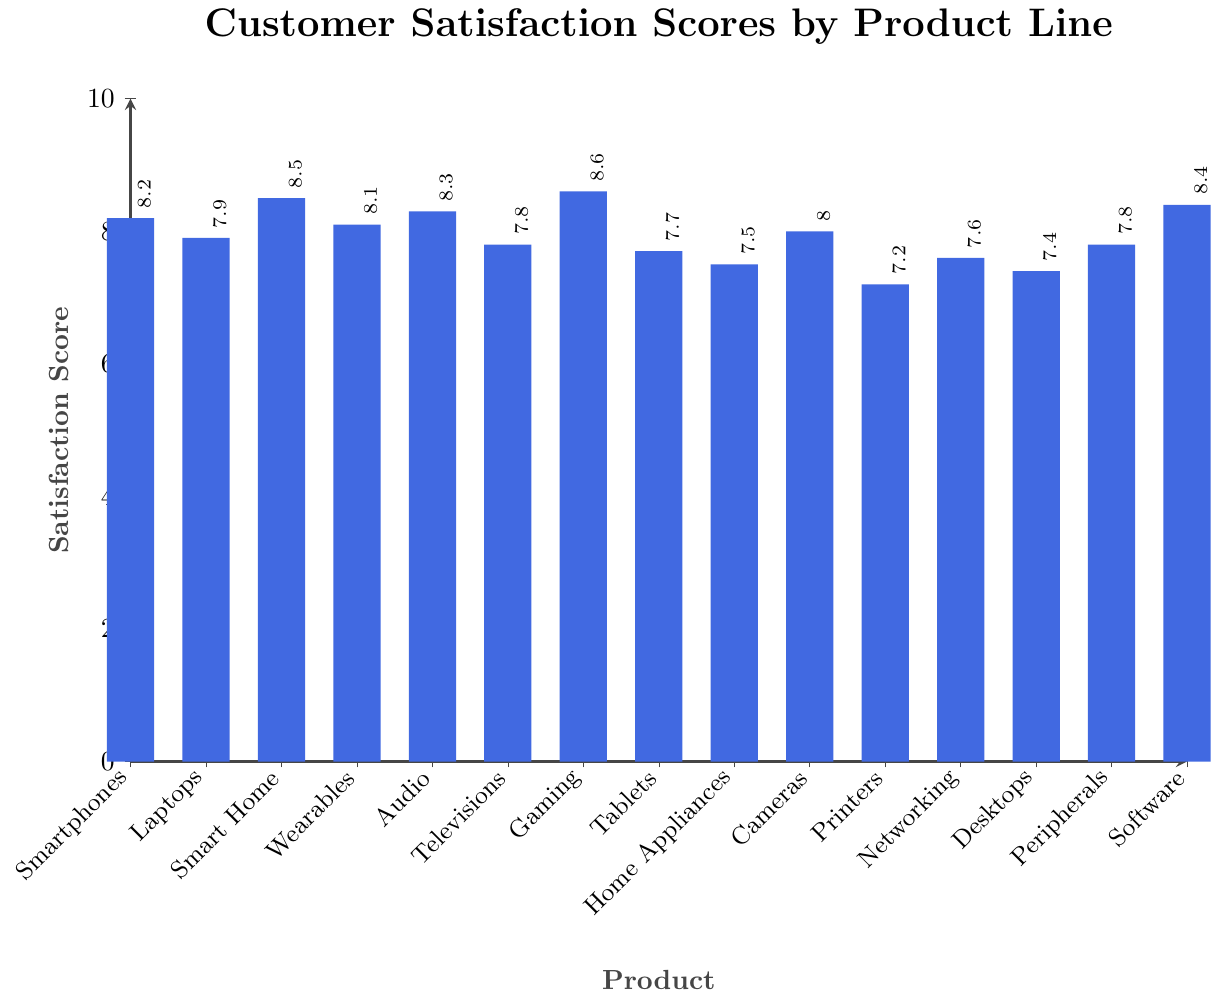Which product line has the highest satisfaction score? The highest bar represents the product line with the highest satisfaction score. The tallest bar corresponds to Gaming Consoles.
Answer: Gaming Consoles Which product line has the lowest satisfaction score? The lowest bar represents the product line with the lowest satisfaction score. The shortest bar corresponds to Printers.
Answer: Printers How many product lines have a satisfaction score of 8.0 or higher? Identify all bars with heights at 8.0 or above and count them. The product lines are Smartphones, Smart Home Devices, Wearables, Audio Products, Gaming Consoles, Cameras, and Software Services.
Answer: 7 What is the difference in satisfaction scores between Smartphones and Televisions? Find the heights of the bars for Smartphones (8.2) and Televisions (7.8) and subtract the latter from the former. The calculation is 8.2 - 7.8.
Answer: 0.4 What is the average satisfaction score of all product lines? Sum all the satisfaction scores and then divide by the number of product lines. The calculation is (8.2 + 7.9 + 8.5 + 8.1 + 8.3 + 7.8 + 8.6 + 7.7 + 7.5 + 8.0 + 7.2 + 7.6 + 7.4 + 7.8 + 8.4) / 15.
Answer: 7.933 Which product lines have a satisfaction score less than 7.5? Identify all bars with heights below 7.5. The product lines are Home Appliances, Printers, Networking Equipment, and Desktop Computers.
Answer: Home Appliances, Printers, Networking Equipment, Desktop Computers Which product line has a score closest to the average satisfaction score? Calculate the average satisfaction score (7.933) and find the product line with a score closest to this value. The closest satisfaction score is 8.0, which corresponds to Cameras.
Answer: Cameras What is the total satisfaction score of Home Appliances, Tablets, and Desktops? Add the satisfaction scores for Home Appliances (7.5), Tablets (7.7), and Desktops (7.4). The calculation is 7.5 + 7.7 + 7.4.
Answer: 22.6 Which product lines have a satisfaction score between 7.5 and 8.0 inclusive? Identify all bars within the height range of 7.5 to 8.0 inclusive. The product lines are Tablets, Cameras, Networking Equipment, Desktops, and Peripherals.
Answer: Tablets, Cameras, Networking Equipment, Desktops, Peripherals What is the range of the satisfaction scores across all product lines? The range is the difference between the highest and lowest satisfaction scores. The highest score is 8.6 (Gaming Consoles) and the lowest is 7.2 (Printers). The calculation is 8.6 - 7.2.
Answer: 1.4 